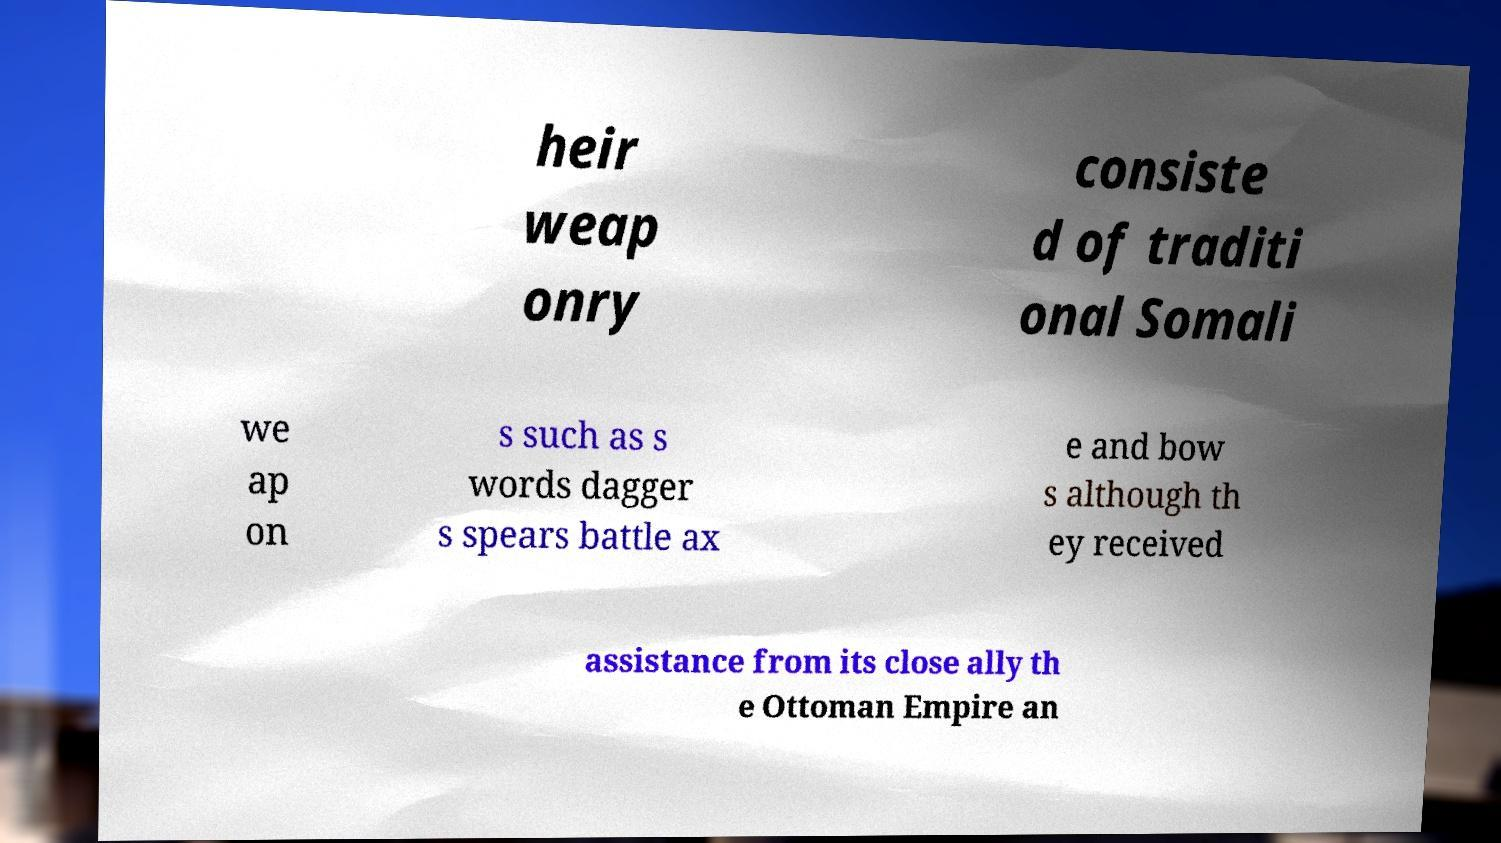Please read and relay the text visible in this image. What does it say? heir weap onry consiste d of traditi onal Somali we ap on s such as s words dagger s spears battle ax e and bow s although th ey received assistance from its close ally th e Ottoman Empire an 